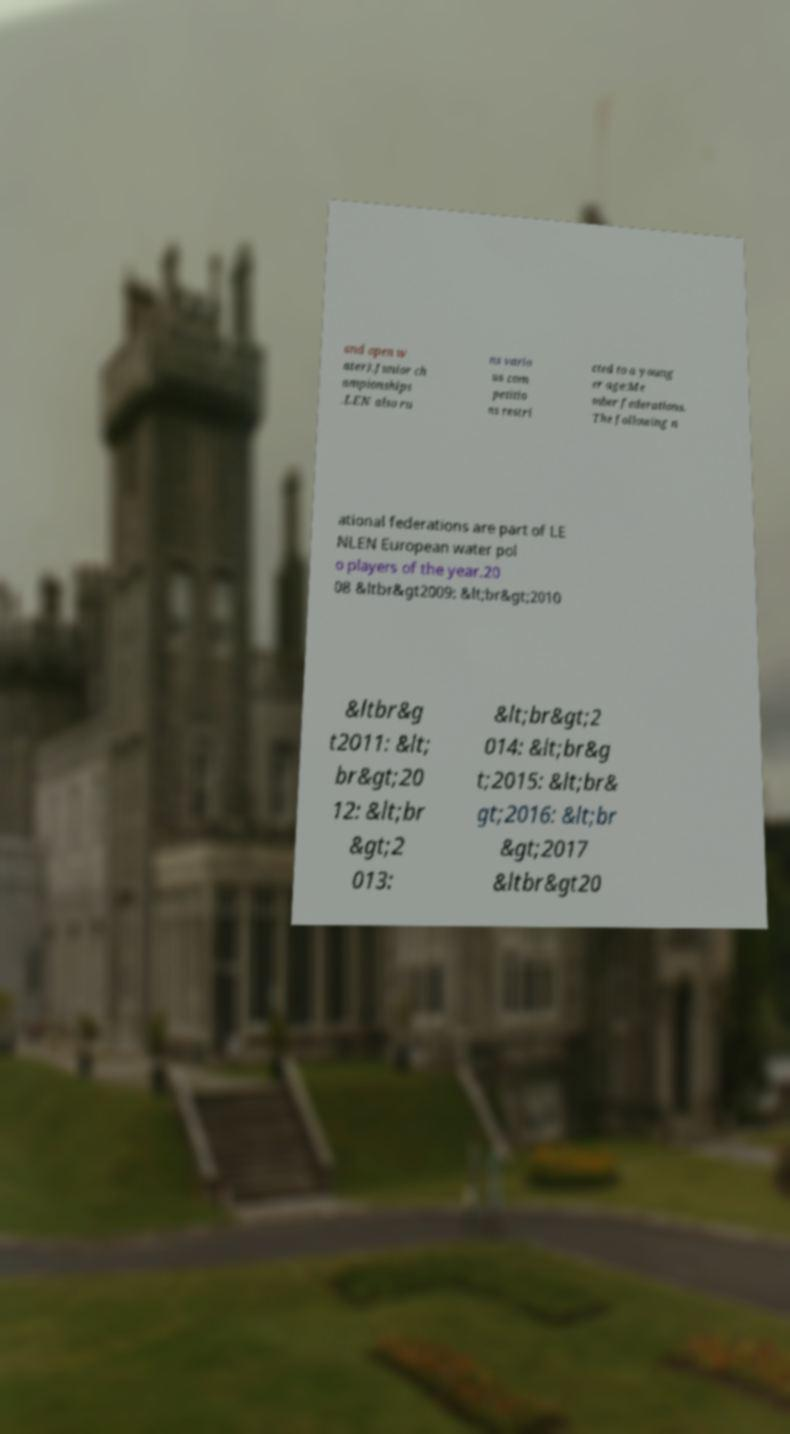Please read and relay the text visible in this image. What does it say? and open w ater).Junior ch ampionships .LEN also ru ns vario us com petitio ns restri cted to a young er age:Me mber federations. The following n ational federations are part of LE NLEN European water pol o players of the year.20 08 &ltbr&gt2009: &lt;br&gt;2010 &ltbr&g t2011: &lt; br&gt;20 12: &lt;br &gt;2 013: &lt;br&gt;2 014: &lt;br&g t;2015: &lt;br& gt;2016: &lt;br &gt;2017 &ltbr&gt20 